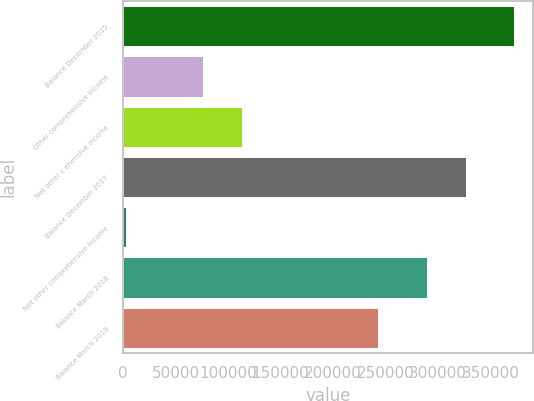Convert chart. <chart><loc_0><loc_0><loc_500><loc_500><bar_chart><fcel>Balance December 2015<fcel>Other comprehensive income<fcel>Net other c ehensive income<fcel>Balance December 2017<fcel>Net other comprehensive income<fcel>Balance March 2018<fcel>Balance March 2019<nl><fcel>372195<fcel>76303.8<fcel>113290<fcel>326604<fcel>2331<fcel>289618<fcel>243184<nl></chart> 